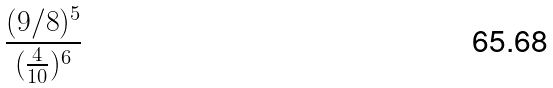<formula> <loc_0><loc_0><loc_500><loc_500>\frac { ( 9 / 8 ) ^ { 5 } } { ( \frac { 4 } { 1 0 } ) ^ { 6 } }</formula> 